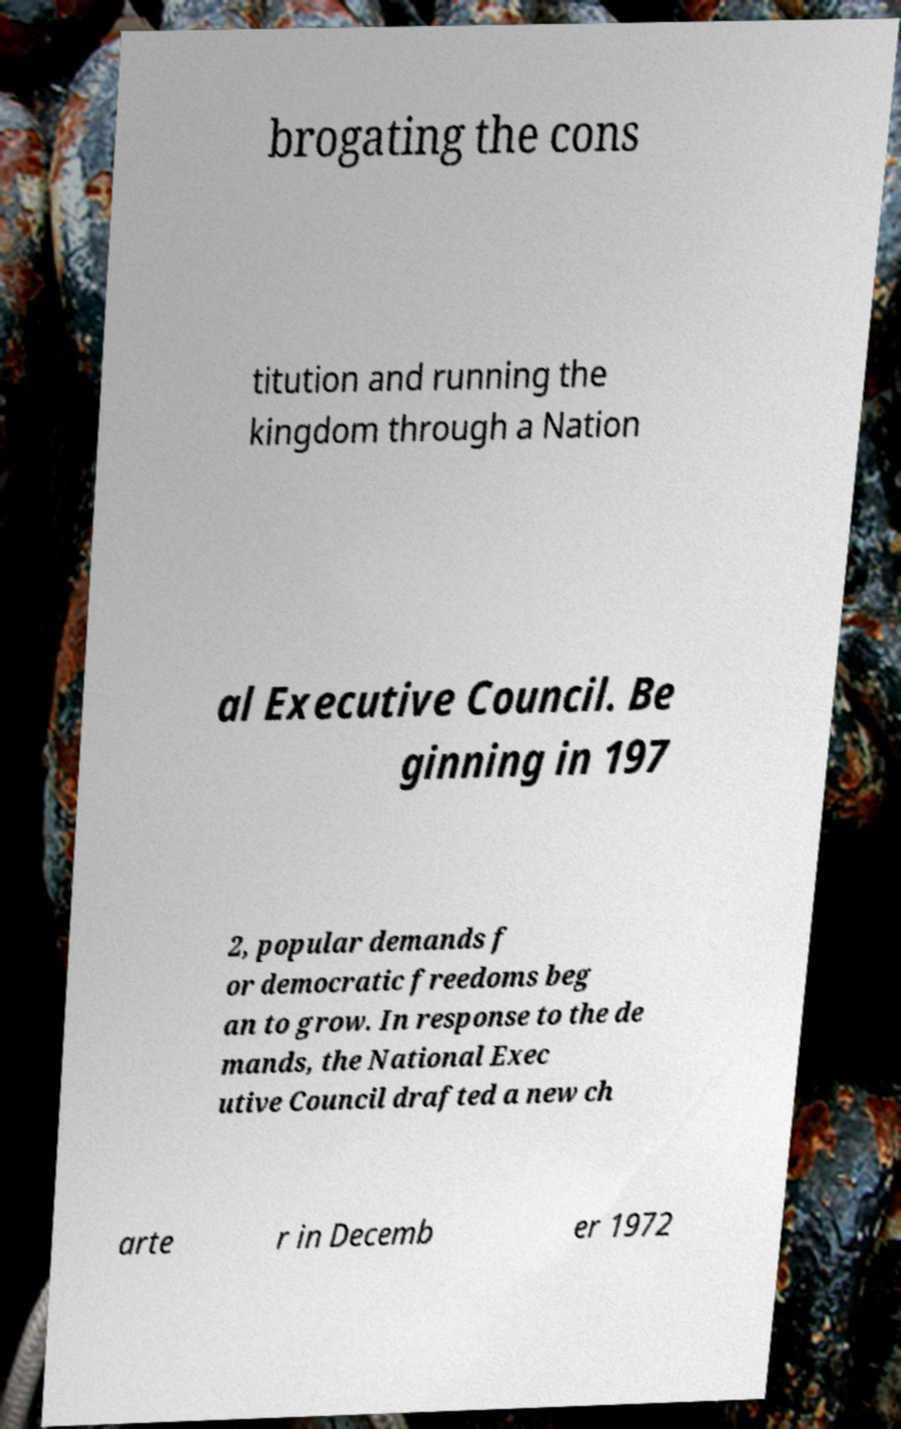Could you extract and type out the text from this image? brogating the cons titution and running the kingdom through a Nation al Executive Council. Be ginning in 197 2, popular demands f or democratic freedoms beg an to grow. In response to the de mands, the National Exec utive Council drafted a new ch arte r in Decemb er 1972 